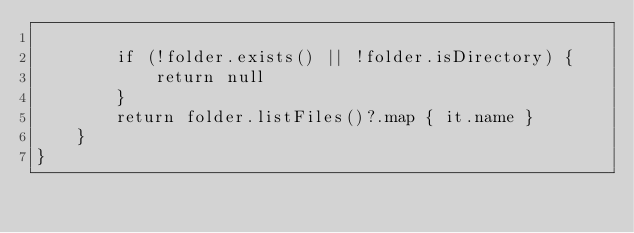<code> <loc_0><loc_0><loc_500><loc_500><_Kotlin_>
        if (!folder.exists() || !folder.isDirectory) {
            return null
        }
        return folder.listFiles()?.map { it.name }
    }
}</code> 